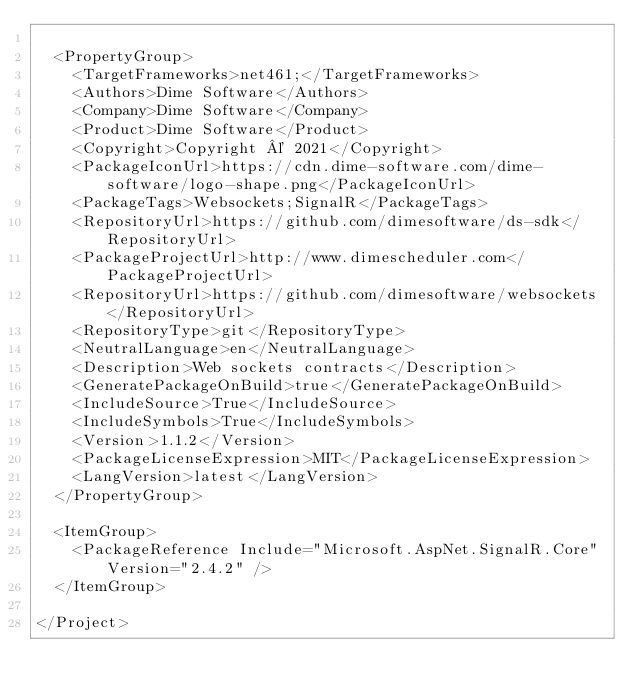Convert code to text. <code><loc_0><loc_0><loc_500><loc_500><_XML_>
  <PropertyGroup>
    <TargetFrameworks>net461;</TargetFrameworks>
    <Authors>Dime Software</Authors>
    <Company>Dime Software</Company>
    <Product>Dime Software</Product>
    <Copyright>Copyright © 2021</Copyright>
    <PackageIconUrl>https://cdn.dime-software.com/dime-software/logo-shape.png</PackageIconUrl>
    <PackageTags>Websockets;SignalR</PackageTags>
    <RepositoryUrl>https://github.com/dimesoftware/ds-sdk</RepositoryUrl>
    <PackageProjectUrl>http://www.dimescheduler.com</PackageProjectUrl>
    <RepositoryUrl>https://github.com/dimesoftware/websockets</RepositoryUrl>
    <RepositoryType>git</RepositoryType>
    <NeutralLanguage>en</NeutralLanguage>
    <Description>Web sockets contracts</Description>
    <GeneratePackageOnBuild>true</GeneratePackageOnBuild>
    <IncludeSource>True</IncludeSource>
    <IncludeSymbols>True</IncludeSymbols>
    <Version>1.1.2</Version>
    <PackageLicenseExpression>MIT</PackageLicenseExpression>
    <LangVersion>latest</LangVersion>
  </PropertyGroup>

  <ItemGroup>
    <PackageReference Include="Microsoft.AspNet.SignalR.Core" Version="2.4.2" />
  </ItemGroup>

</Project>
</code> 